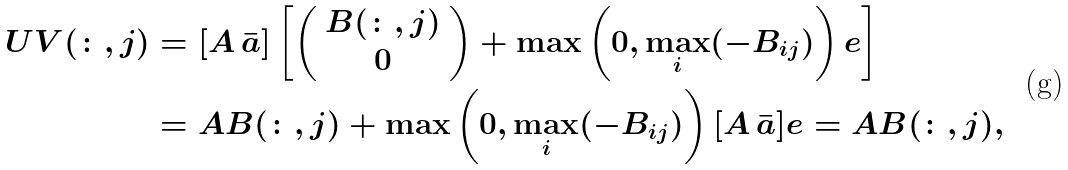Convert formula to latex. <formula><loc_0><loc_0><loc_500><loc_500>U V ( \colon , j ) & = [ A \, \bar { a } ] \left [ \left ( \begin{array} { c } B ( \colon , j ) \\ 0 \end{array} \right ) + \max \left ( 0 , \max _ { i } ( - B _ { i j } ) \right ) e \right ] \\ & = A B ( \colon , j ) + \max \left ( 0 , \max _ { i } ( - B _ { i j } ) \right ) [ A \, \bar { a } ] e = A B ( \colon , j ) ,</formula> 